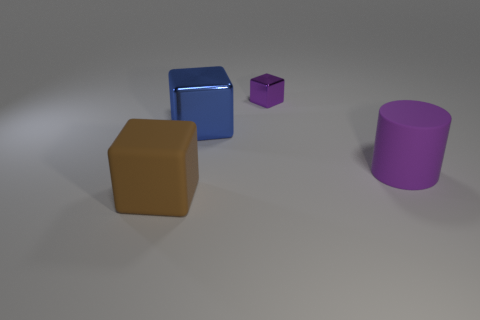Are there any other things that are the same size as the purple shiny block?
Your answer should be compact. No. Is the shape of the rubber object right of the large brown thing the same as the thing that is in front of the purple matte cylinder?
Provide a short and direct response. No. What number of large blue shiny balls are there?
Your answer should be very brief. 0. There is a large thing that is made of the same material as the purple cylinder; what is its shape?
Keep it short and to the point. Cube. Is there any other thing that has the same color as the large rubber cylinder?
Keep it short and to the point. Yes. There is a large metal object; is it the same color as the matte thing that is on the right side of the big brown matte cube?
Make the answer very short. No. Is the number of big blue blocks to the right of the cylinder less than the number of purple shiny things?
Your answer should be compact. Yes. There is a large cube behind the brown matte block; what is its material?
Keep it short and to the point. Metal. What number of other things are there of the same size as the brown thing?
Your answer should be compact. 2. There is a blue object; is it the same size as the purple metallic thing to the right of the big brown block?
Keep it short and to the point. No. 